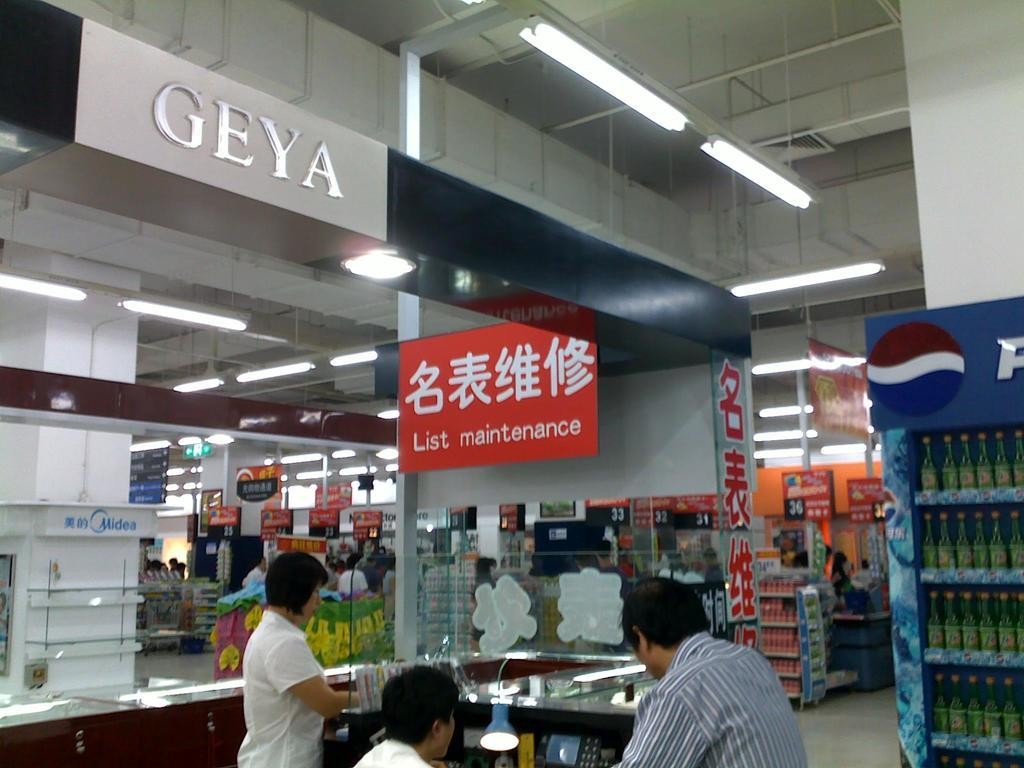<image>
Summarize the visual content of the image. A man is at a desk in a large store under a sign that said List Maintenance. 